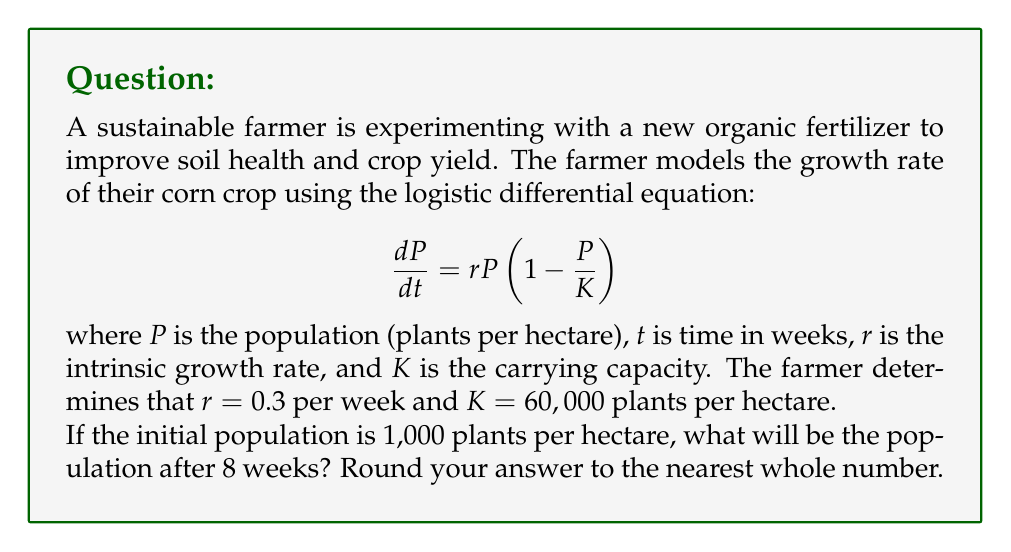Help me with this question. To solve this problem, we need to use the solution to the logistic differential equation:

$$P(t) = \frac{K}{1 + (\frac{K}{P_0} - 1)e^{-rt}}$$

Where:
- $P(t)$ is the population at time $t$
- $K$ is the carrying capacity (60,000 plants/hectare)
- $P_0$ is the initial population (1,000 plants/hectare)
- $r$ is the intrinsic growth rate (0.3 per week)
- $t$ is the time (8 weeks)

Let's substitute these values into the equation:

$$P(8) = \frac{60,000}{1 + (\frac{60,000}{1,000} - 1)e^{-0.3 \cdot 8}}$$

Now, let's solve this step-by-step:

1) First, simplify the fraction inside the parentheses:
   $$\frac{60,000}{1,000} - 1 = 60 - 1 = 59$$

2) Calculate the exponent:
   $$-0.3 \cdot 8 = -2.4$$

3) Now our equation looks like this:
   $$P(8) = \frac{60,000}{1 + 59e^{-2.4}}$$

4) Calculate $e^{-2.4}$:
   $$e^{-2.4} \approx 0.0907$$

5) Multiply:
   $$59 \cdot 0.0907 \approx 5.3513$$

6) Add 1:
   $$1 + 5.3513 = 6.3513$$

7) Divide:
   $$\frac{60,000}{6.3513} \approx 9,446.89$$

8) Round to the nearest whole number:
   $$P(8) \approx 9,447$$

Therefore, after 8 weeks, the population will be approximately 9,447 plants per hectare.
Answer: 9,447 plants per hectare 